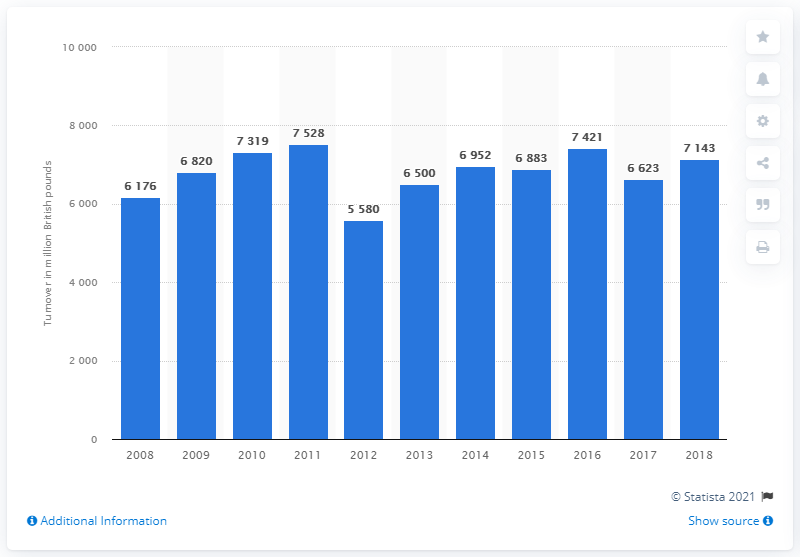Give some essential details in this illustration. The total retail sales turnover from DIY supplies in the UK in 2018 was approximately 7,143. In 2012, retail sales turnover from DIY supplies decreased by [amount]. In 2018, retail sales turnover from DIY supplies decreased by [amount]. 